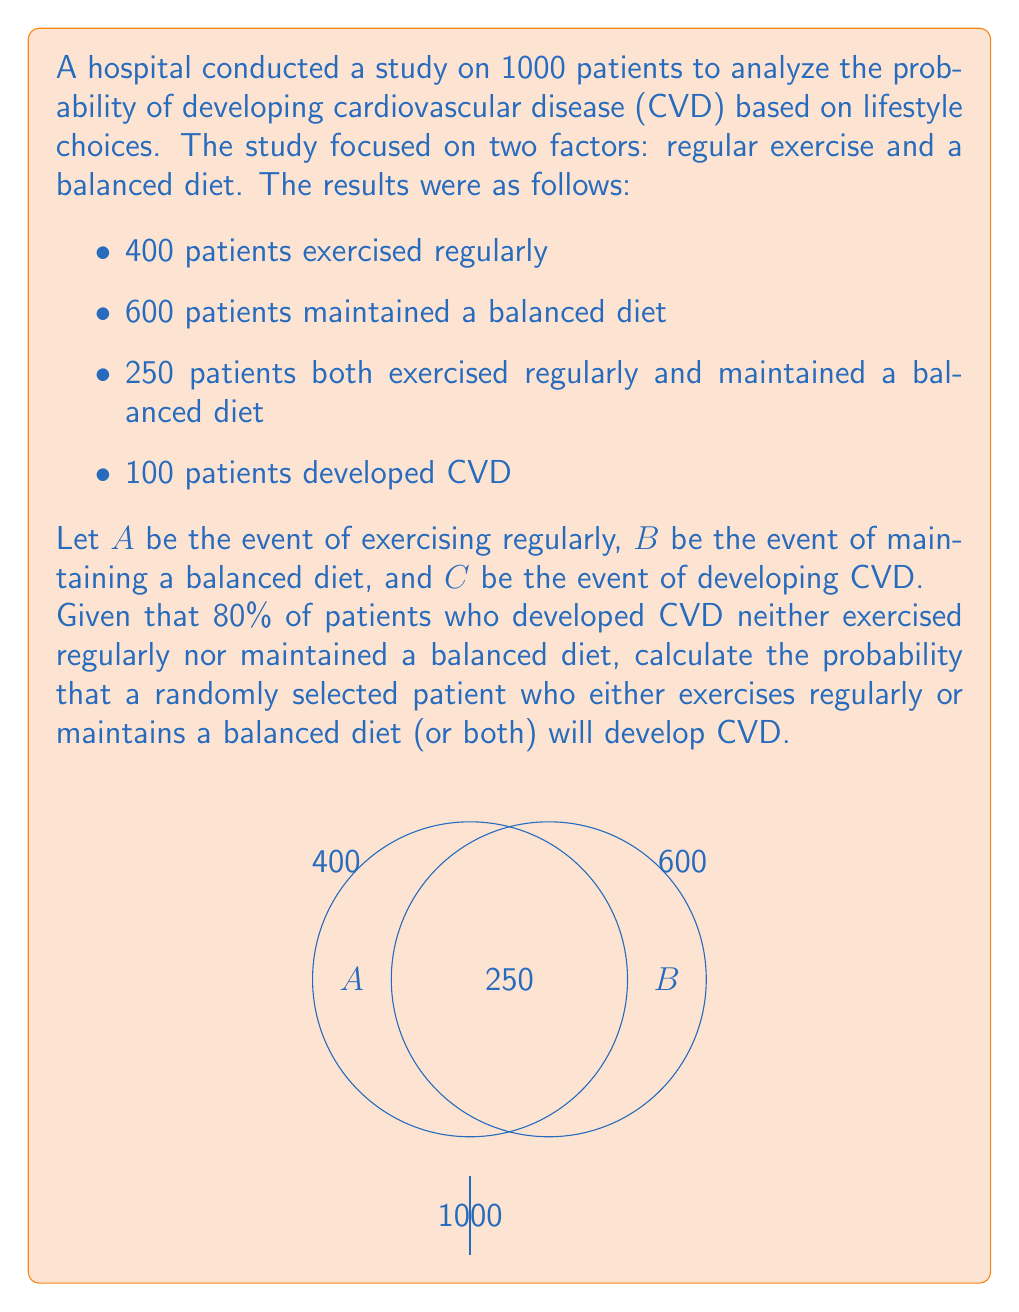Could you help me with this problem? Let's approach this step-by-step:

1) First, let's calculate the number of patients who either exercise regularly or maintain a balanced diet (or both):
   $n(A \cup B) = n(A) + n(B) - n(A \cap B) = 400 + 600 - 250 = 750$

2) We're told that 80% of patients who developed CVD neither exercised regularly nor maintained a balanced diet. This means:
   $n(C \cap (A \cup B)^c) = 0.8 \times 100 = 80$

3) Therefore, the number of patients who developed CVD and either exercised regularly or maintained a balanced diet (or both) is:
   $n(C \cap (A \cup B)) = 100 - 80 = 20$

4) Now we can calculate the probability:

   $P(C | A \cup B) = \frac{n(C \cap (A \cup B))}{n(A \cup B)} = \frac{20}{750} = \frac{2}{75} \approx 0.0267$

Thus, the probability that a randomly selected patient who either exercises regularly or maintains a balanced diet (or both) will develop CVD is $\frac{2}{75}$ or approximately 2.67%.
Answer: $\frac{2}{75}$ 